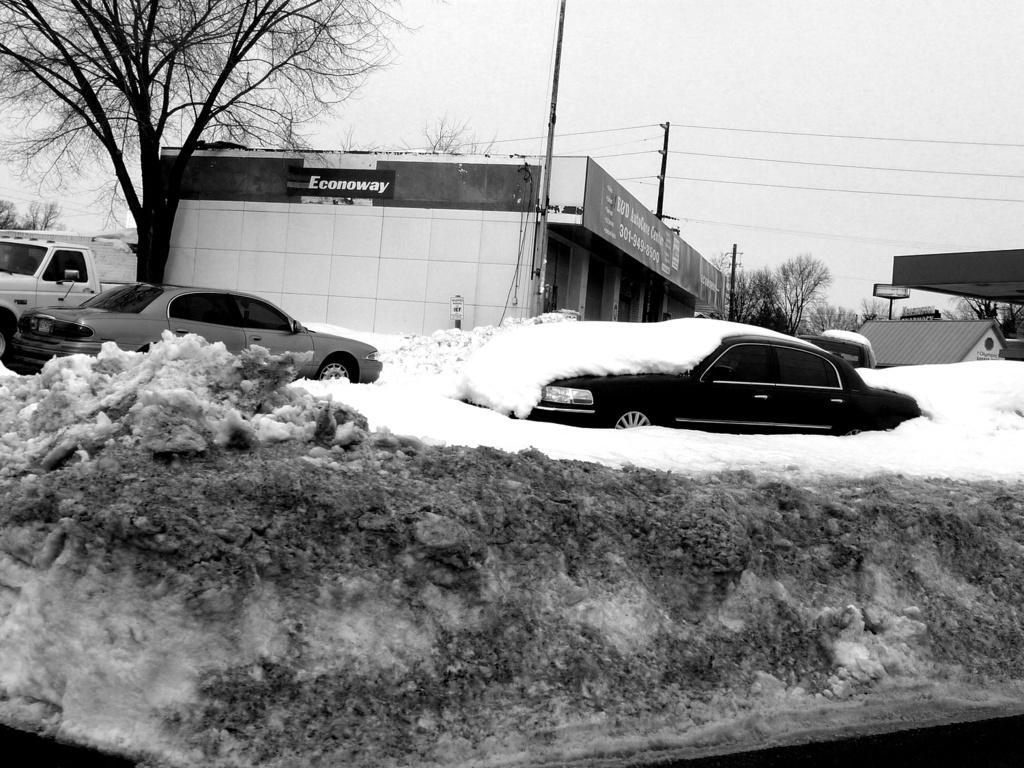In one or two sentences, can you explain what this image depicts? This is a black and white picture, in the back there are few cars covered with snow with buildings and trees behind it and above its sky. 